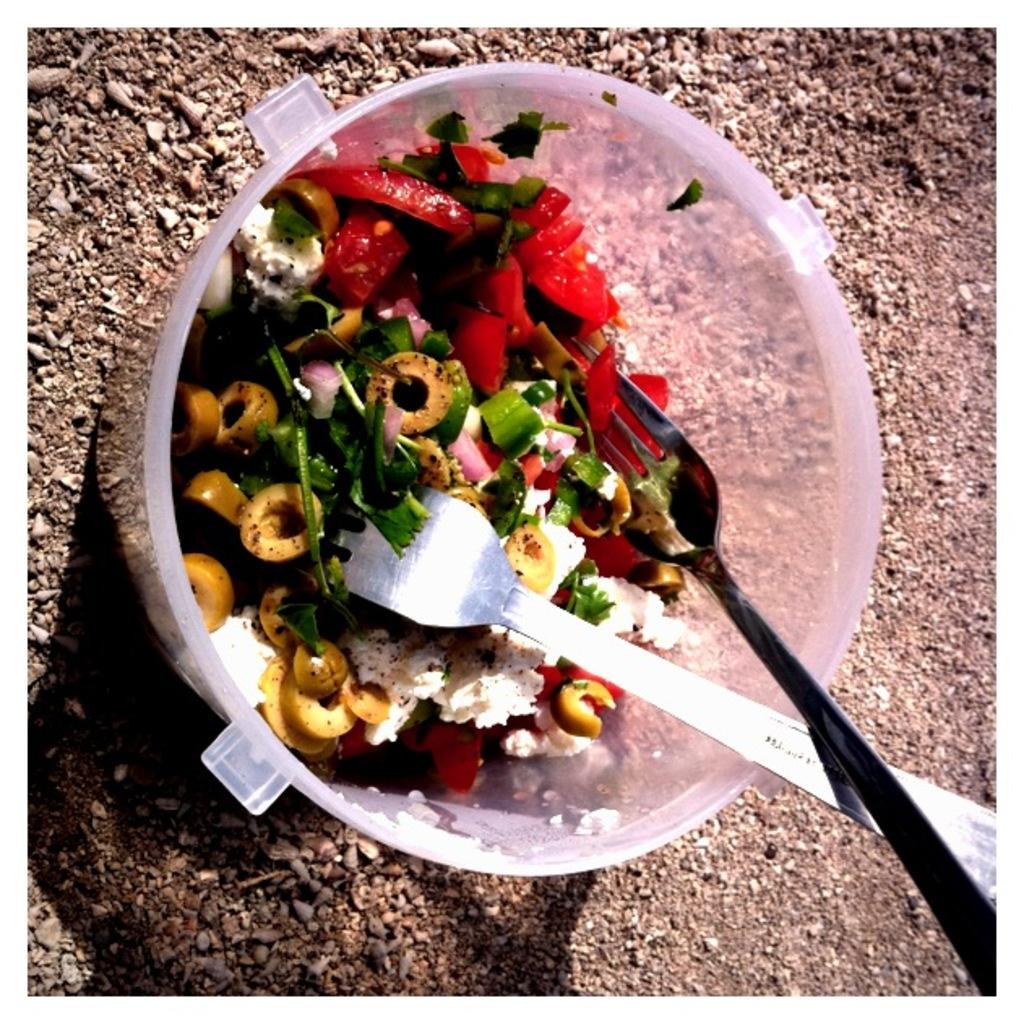What is present in the image that can hold food? There is a bowl in the image that can hold food. What can be seen on the ground in the image? There are stones on the ground in the image. What is inside the bowl in the image? The bowl contains food. What utensils are present in the bowl? There are forks in the bowl. What type of muscle can be seen flexing in the image? There is no muscle visible in the image; it only contains a bowl, stones, food, and forks. 